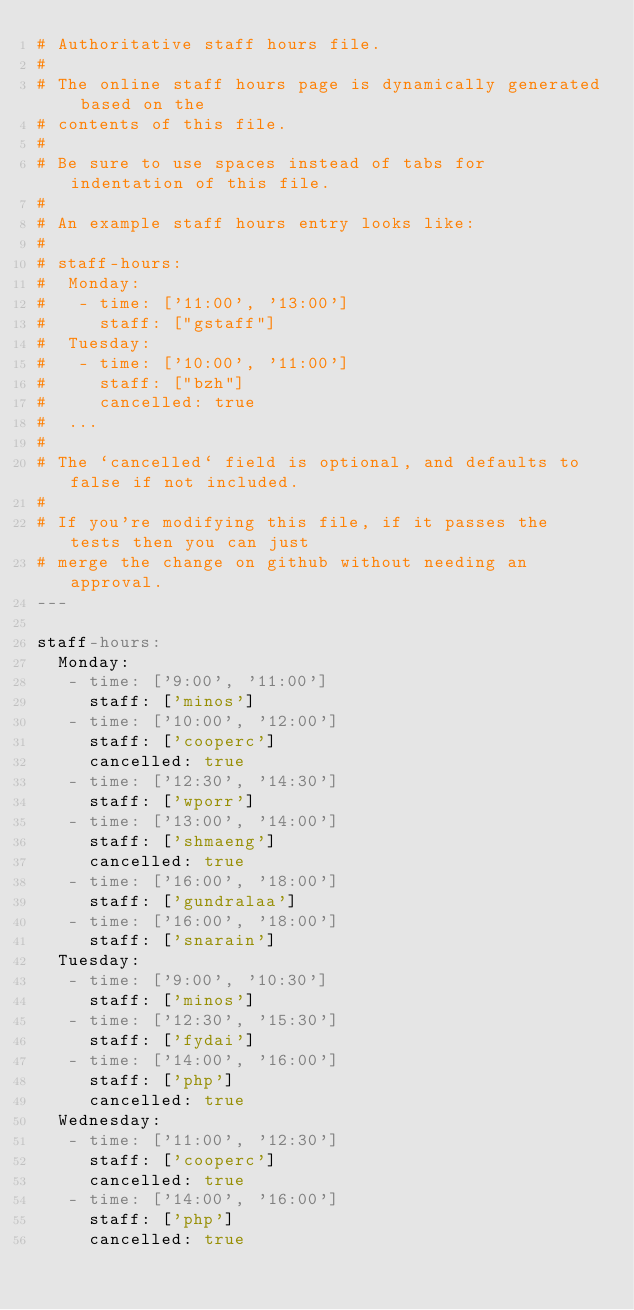Convert code to text. <code><loc_0><loc_0><loc_500><loc_500><_YAML_># Authoritative staff hours file.
#
# The online staff hours page is dynamically generated based on the
# contents of this file.
#
# Be sure to use spaces instead of tabs for indentation of this file.
#
# An example staff hours entry looks like:
#
# staff-hours:
#  Monday:
#   - time: ['11:00', '13:00']
#     staff: ["gstaff"]
#  Tuesday:
#   - time: ['10:00', '11:00']
#     staff: ["bzh"]
#     cancelled: true
#  ...
#
# The `cancelled` field is optional, and defaults to false if not included.
#
# If you're modifying this file, if it passes the tests then you can just
# merge the change on github without needing an approval.
---

staff-hours:
  Monday:
   - time: ['9:00', '11:00']
     staff: ['minos']
   - time: ['10:00', '12:00']
     staff: ['cooperc']
     cancelled: true
   - time: ['12:30', '14:30']
     staff: ['wporr']
   - time: ['13:00', '14:00']
     staff: ['shmaeng']
     cancelled: true
   - time: ['16:00', '18:00']
     staff: ['gundralaa']
   - time: ['16:00', '18:00']
     staff: ['snarain']
  Tuesday:
   - time: ['9:00', '10:30']
     staff: ['minos']
   - time: ['12:30', '15:30']
     staff: ['fydai']
   - time: ['14:00', '16:00']
     staff: ['php']
     cancelled: true
  Wednesday:
   - time: ['11:00', '12:30']
     staff: ['cooperc']
     cancelled: true
   - time: ['14:00', '16:00']
     staff: ['php']
     cancelled: true</code> 